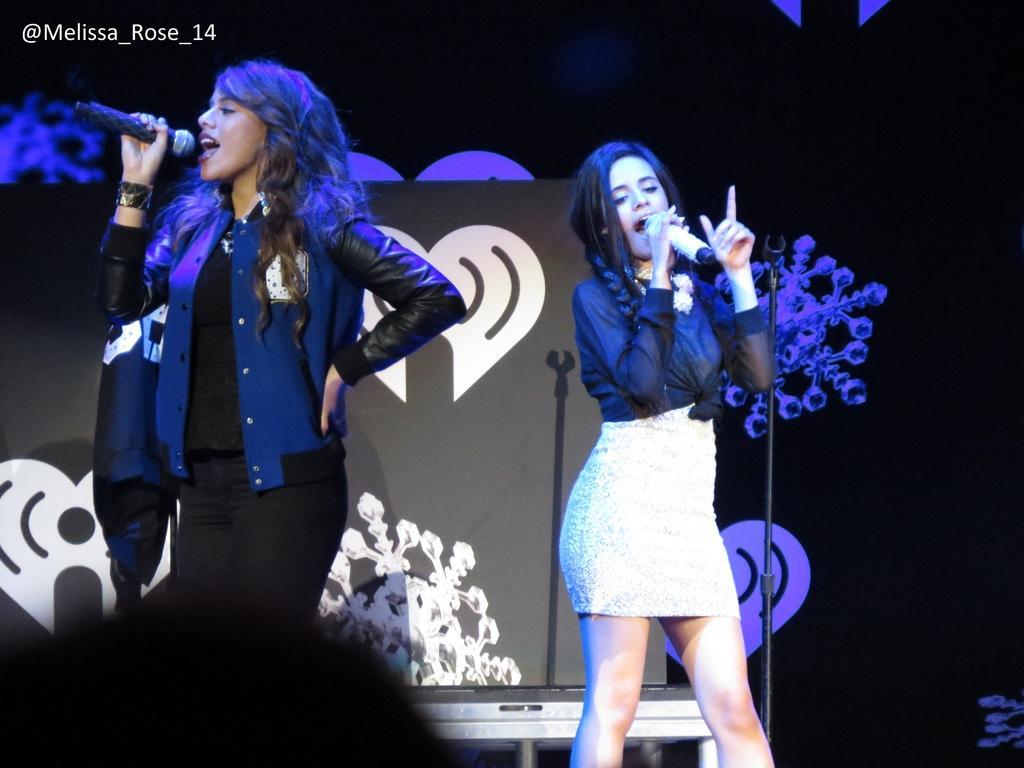Please provide a concise description of this image. In this picture we can see two women holding microphones and singing. On the right side of the women, there is a stand. Behind the women, there is a board, some objects and a dark background. In the top left corner of the image, there is a watermark. 